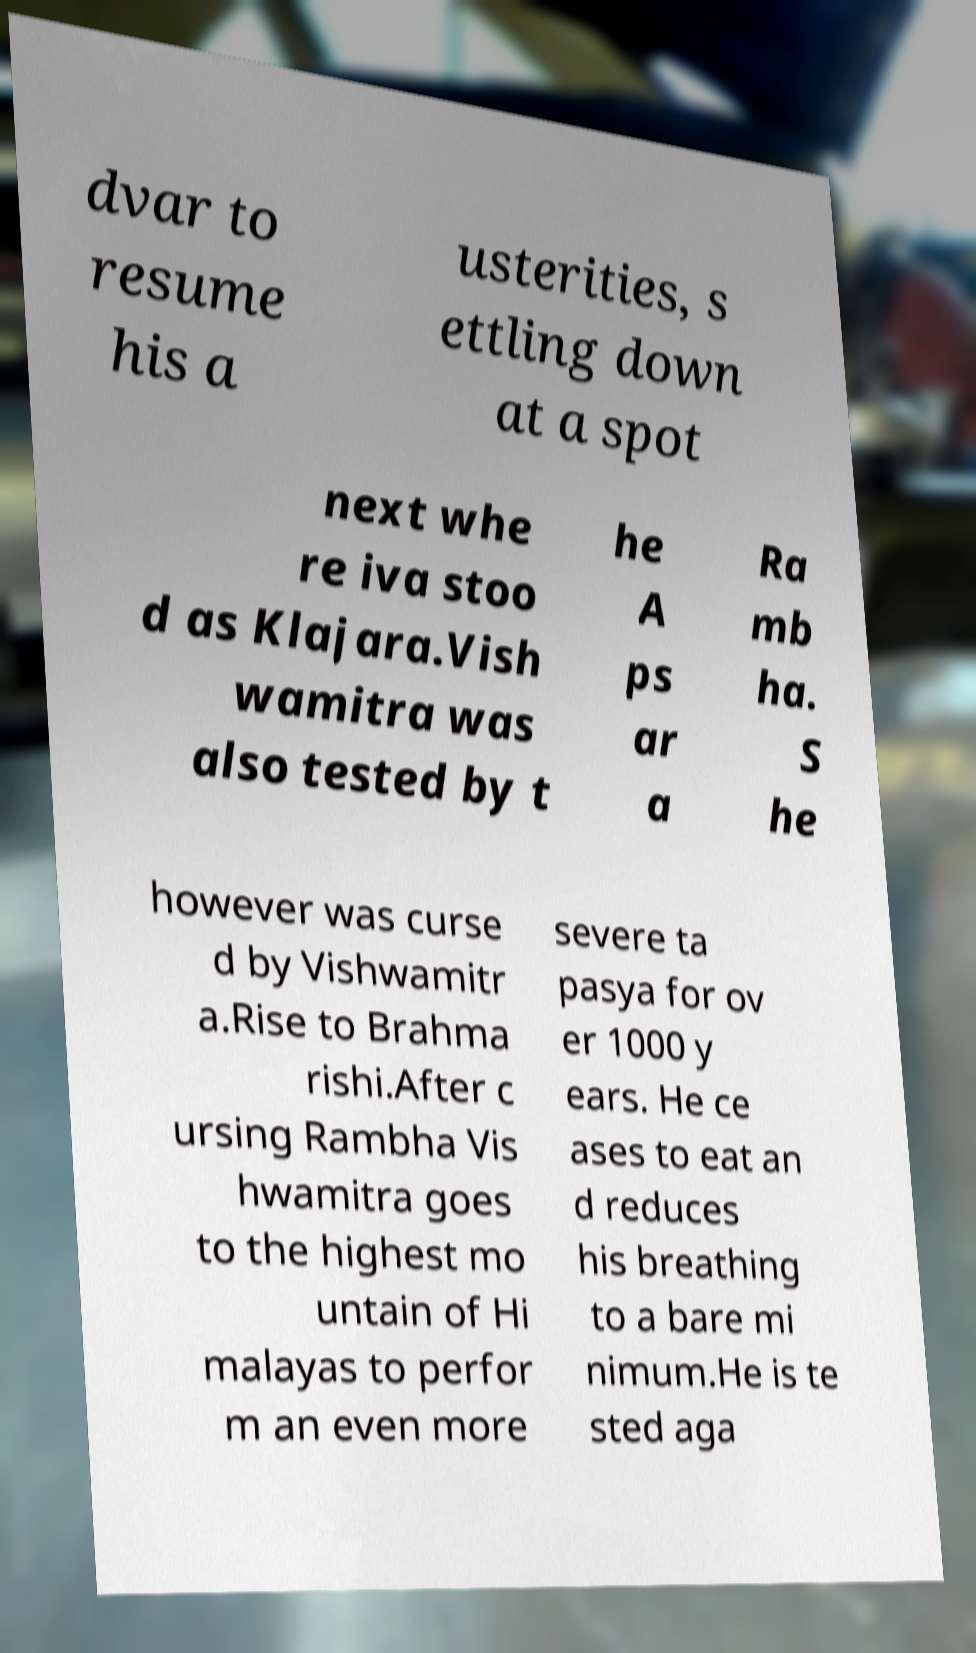Can you read and provide the text displayed in the image?This photo seems to have some interesting text. Can you extract and type it out for me? dvar to resume his a usterities, s ettling down at a spot next whe re iva stoo d as Klajara.Vish wamitra was also tested by t he A ps ar a Ra mb ha. S he however was curse d by Vishwamitr a.Rise to Brahma rishi.After c ursing Rambha Vis hwamitra goes to the highest mo untain of Hi malayas to perfor m an even more severe ta pasya for ov er 1000 y ears. He ce ases to eat an d reduces his breathing to a bare mi nimum.He is te sted aga 